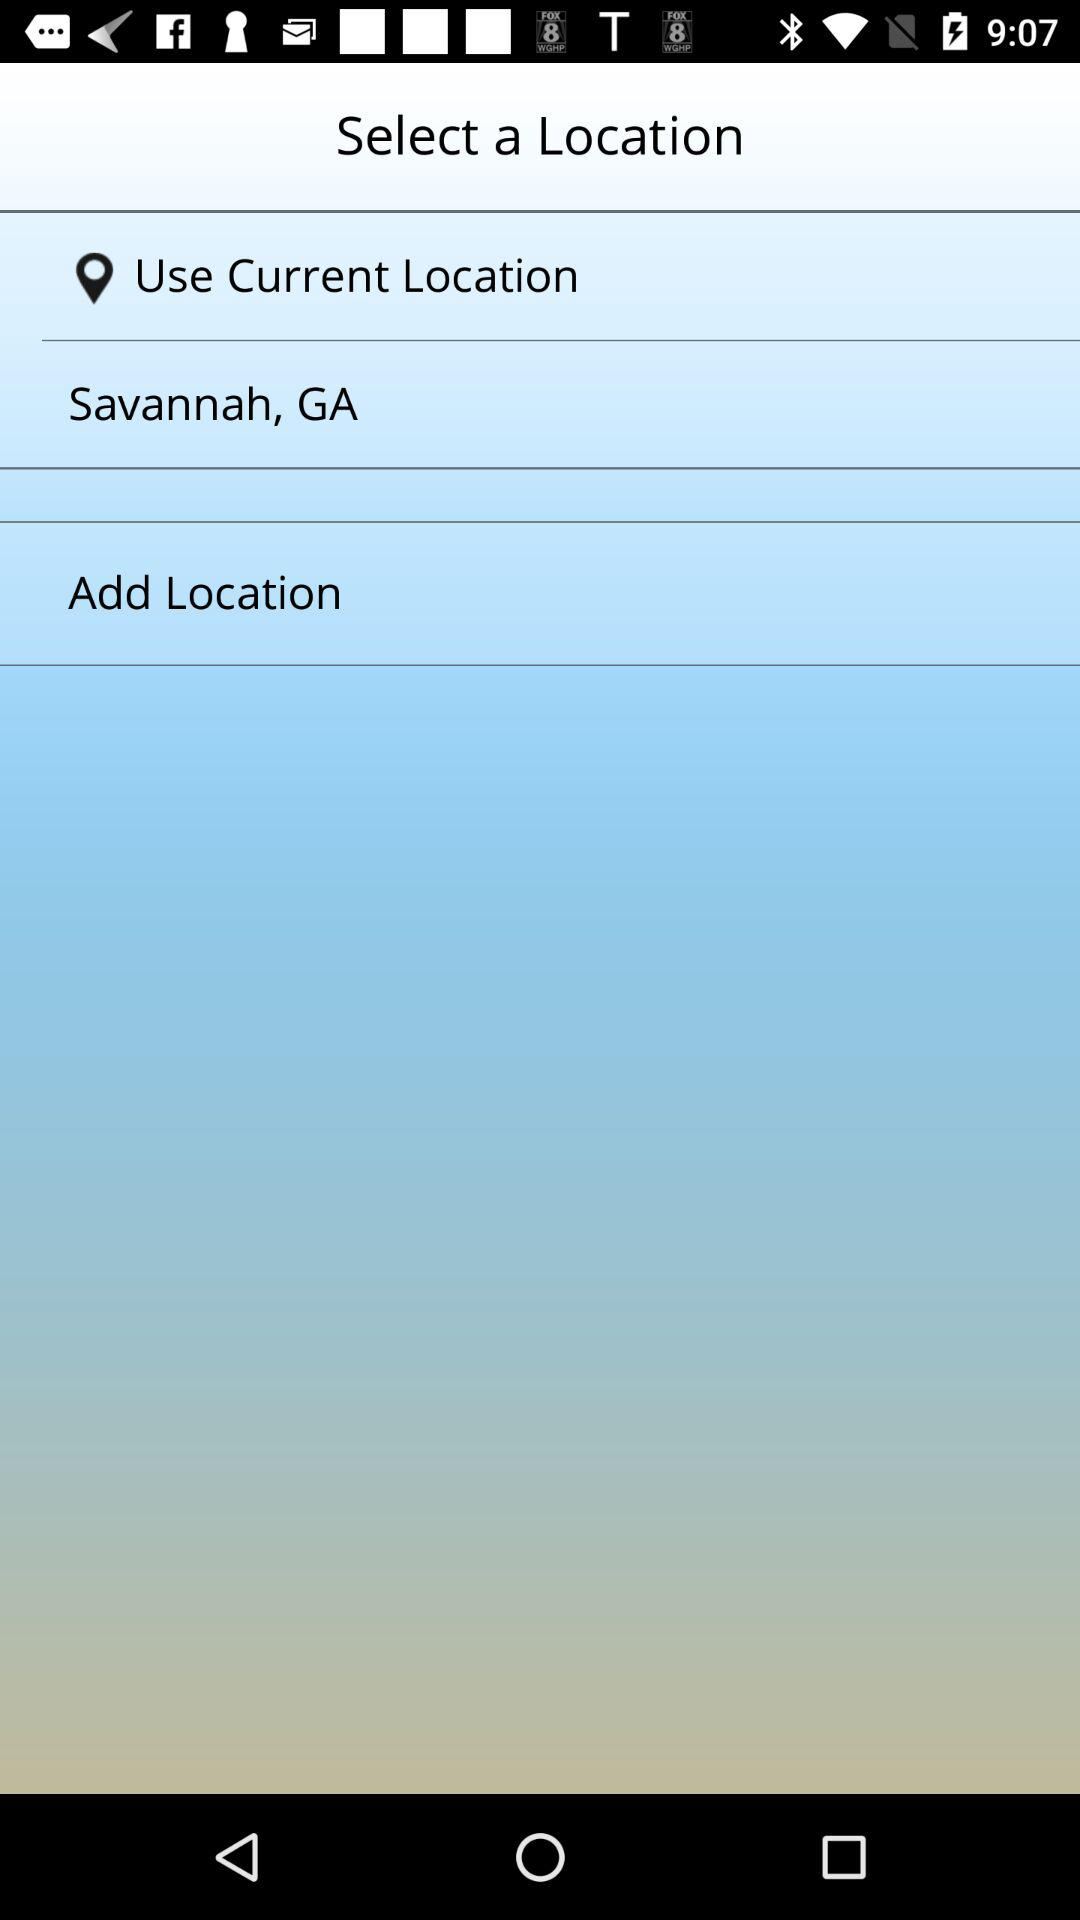How many items are below the text Select a Location?
Answer the question using a single word or phrase. 3 